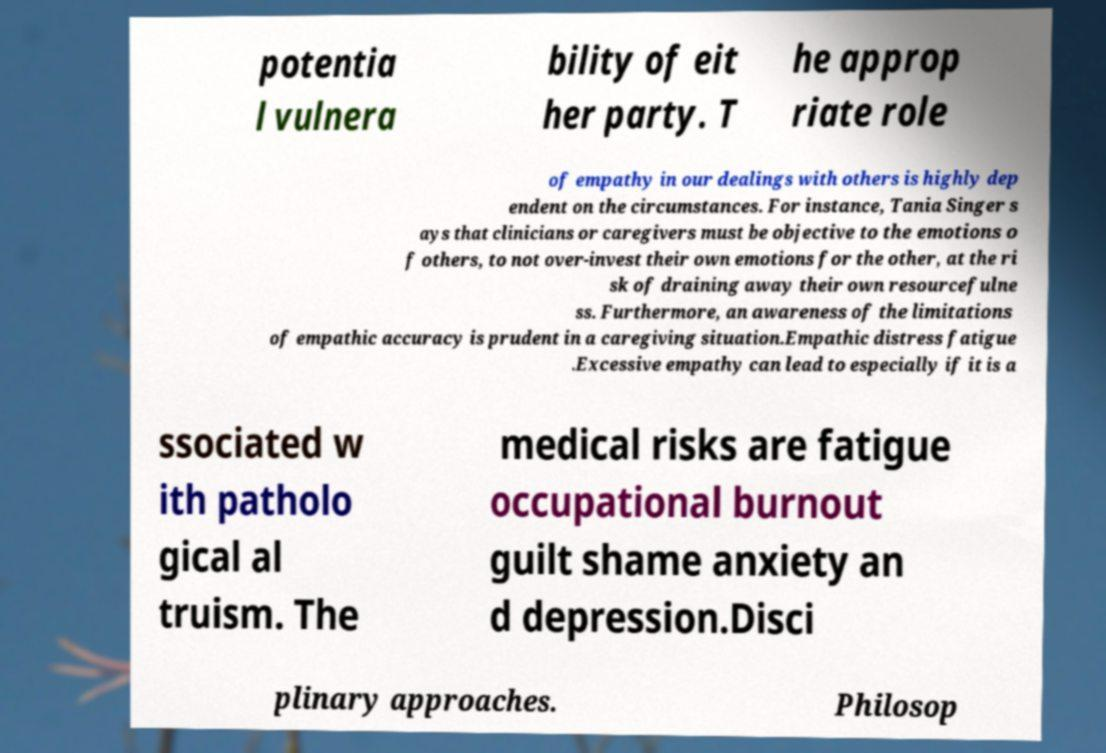There's text embedded in this image that I need extracted. Can you transcribe it verbatim? potentia l vulnera bility of eit her party. T he approp riate role of empathy in our dealings with others is highly dep endent on the circumstances. For instance, Tania Singer s ays that clinicians or caregivers must be objective to the emotions o f others, to not over-invest their own emotions for the other, at the ri sk of draining away their own resourcefulne ss. Furthermore, an awareness of the limitations of empathic accuracy is prudent in a caregiving situation.Empathic distress fatigue .Excessive empathy can lead to especially if it is a ssociated w ith patholo gical al truism. The medical risks are fatigue occupational burnout guilt shame anxiety an d depression.Disci plinary approaches. Philosop 